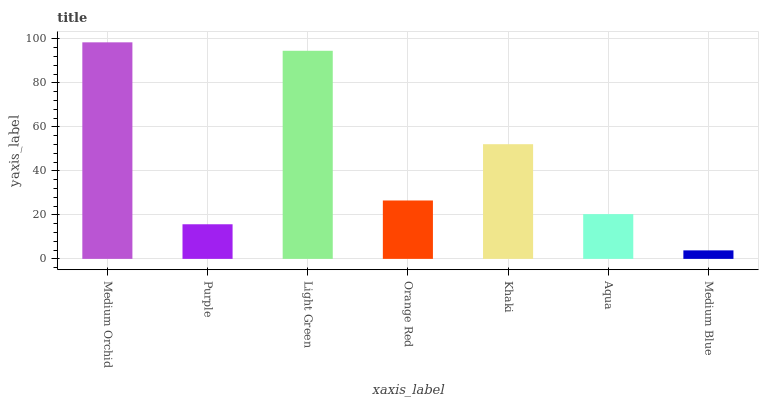Is Medium Blue the minimum?
Answer yes or no. Yes. Is Medium Orchid the maximum?
Answer yes or no. Yes. Is Purple the minimum?
Answer yes or no. No. Is Purple the maximum?
Answer yes or no. No. Is Medium Orchid greater than Purple?
Answer yes or no. Yes. Is Purple less than Medium Orchid?
Answer yes or no. Yes. Is Purple greater than Medium Orchid?
Answer yes or no. No. Is Medium Orchid less than Purple?
Answer yes or no. No. Is Orange Red the high median?
Answer yes or no. Yes. Is Orange Red the low median?
Answer yes or no. Yes. Is Aqua the high median?
Answer yes or no. No. Is Medium Blue the low median?
Answer yes or no. No. 